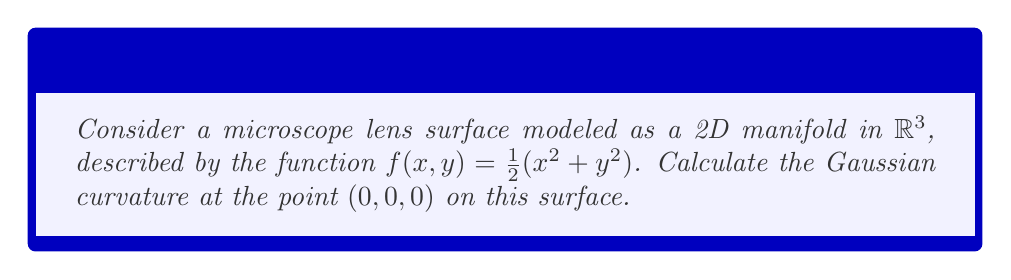Teach me how to tackle this problem. To calculate the Gaussian curvature of a 2D manifold representing a microscope lens surface, we'll follow these steps:

1) The surface is given by $z = f(x,y) = \frac{1}{2}(x^2 + y^2)$

2) We need to calculate the first and second fundamental forms. Let's start with the partial derivatives:

   $f_x = x$
   $f_y = y$
   $f_{xx} = 1$
   $f_{xy} = 0$
   $f_{yy} = 1$

3) The components of the first fundamental form are:
   $E = 1 + f_x^2 = 1 + x^2$
   $F = f_x f_y = xy$
   $G = 1 + f_y^2 = 1 + y^2$

4) The components of the second fundamental form are:
   $L = \frac{f_{xx}}{\sqrt{1 + f_x^2 + f_y^2}} = \frac{1}{\sqrt{1 + x^2 + y^2}}$
   $M = \frac{f_{xy}}{\sqrt{1 + f_x^2 + f_y^2}} = 0$
   $N = \frac{f_{yy}}{\sqrt{1 + f_x^2 + f_y^2}} = \frac{1}{\sqrt{1 + x^2 + y^2}}$

5) The Gaussian curvature K is given by:

   $$K = \frac{LN - M^2}{EG - F^2}$$

6) At the point (0,0,0), we have:
   $E = G = 1$, $F = 0$
   $L = N = 1$, $M = 0$

7) Substituting these values:

   $$K = \frac{(1)(1) - 0^2}{(1)(1) - 0^2} = 1$$

Therefore, the Gaussian curvature at the point (0,0,0) is 1.
Answer: The Gaussian curvature at the point (0,0,0) on the microscope lens surface is 1. 